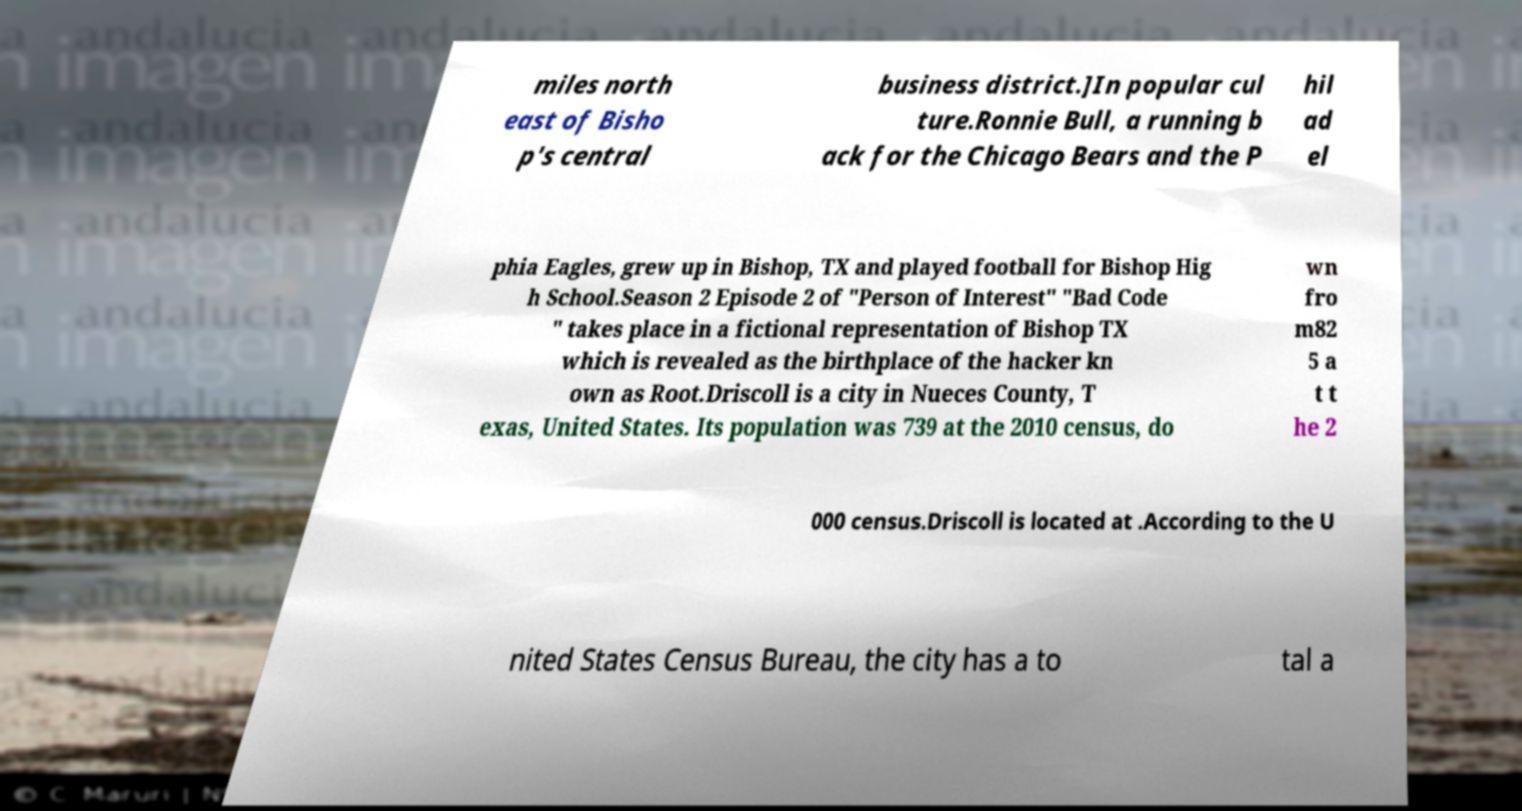For documentation purposes, I need the text within this image transcribed. Could you provide that? miles north east of Bisho p's central business district.]In popular cul ture.Ronnie Bull, a running b ack for the Chicago Bears and the P hil ad el phia Eagles, grew up in Bishop, TX and played football for Bishop Hig h School.Season 2 Episode 2 of "Person of Interest" "Bad Code " takes place in a fictional representation of Bishop TX which is revealed as the birthplace of the hacker kn own as Root.Driscoll is a city in Nueces County, T exas, United States. Its population was 739 at the 2010 census, do wn fro m82 5 a t t he 2 000 census.Driscoll is located at .According to the U nited States Census Bureau, the city has a to tal a 